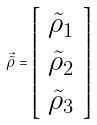<formula> <loc_0><loc_0><loc_500><loc_500>\vec { { \tilde { \rho } } } = \left [ \begin{array} { c } \tilde { \rho } _ { 1 } \\ \tilde { \rho } _ { 2 } \\ \tilde { \rho } _ { 3 } \end{array} \right ]</formula> 